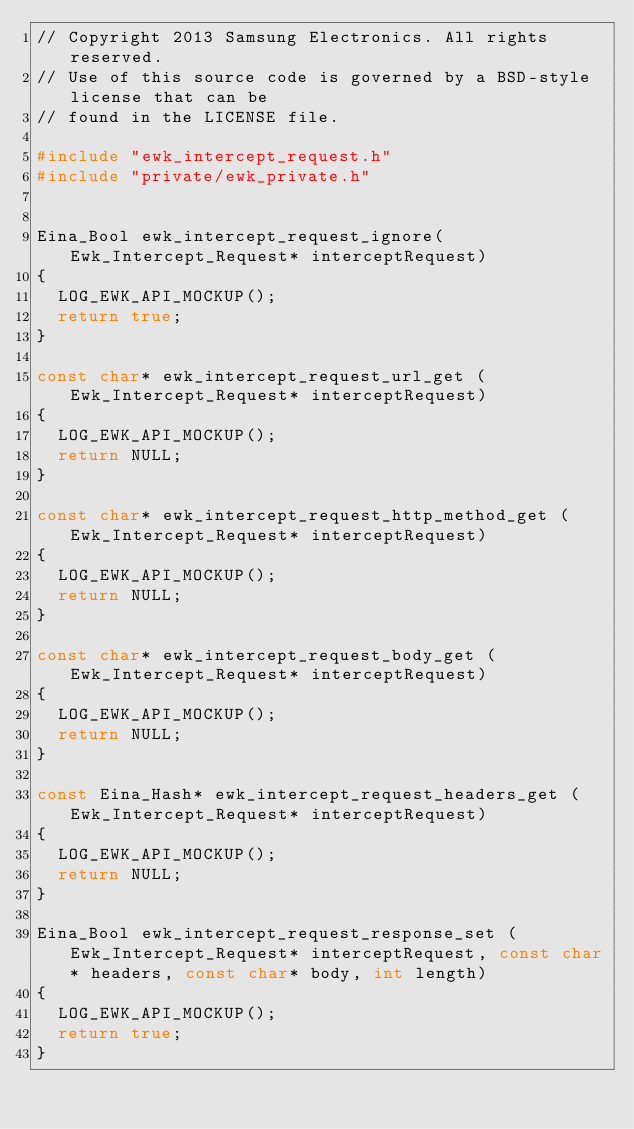Convert code to text. <code><loc_0><loc_0><loc_500><loc_500><_C++_>// Copyright 2013 Samsung Electronics. All rights reserved.
// Use of this source code is governed by a BSD-style license that can be
// found in the LICENSE file.

#include "ewk_intercept_request.h"
#include "private/ewk_private.h"


Eina_Bool ewk_intercept_request_ignore(Ewk_Intercept_Request* interceptRequest)
{
  LOG_EWK_API_MOCKUP();
  return true;
}

const char* ewk_intercept_request_url_get (Ewk_Intercept_Request* interceptRequest)
{
  LOG_EWK_API_MOCKUP();
  return NULL;
}

const char* ewk_intercept_request_http_method_get (Ewk_Intercept_Request* interceptRequest)
{
  LOG_EWK_API_MOCKUP();
  return NULL;
}

const char* ewk_intercept_request_body_get (Ewk_Intercept_Request* interceptRequest)
{
  LOG_EWK_API_MOCKUP();
  return NULL;
}

const Eina_Hash* ewk_intercept_request_headers_get (Ewk_Intercept_Request* interceptRequest)
{
  LOG_EWK_API_MOCKUP();
  return NULL;
}

Eina_Bool ewk_intercept_request_response_set (Ewk_Intercept_Request* interceptRequest, const char* headers, const char* body, int length)
{
  LOG_EWK_API_MOCKUP();
  return true;
}

</code> 